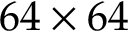<formula> <loc_0><loc_0><loc_500><loc_500>6 4 \times 6 4</formula> 